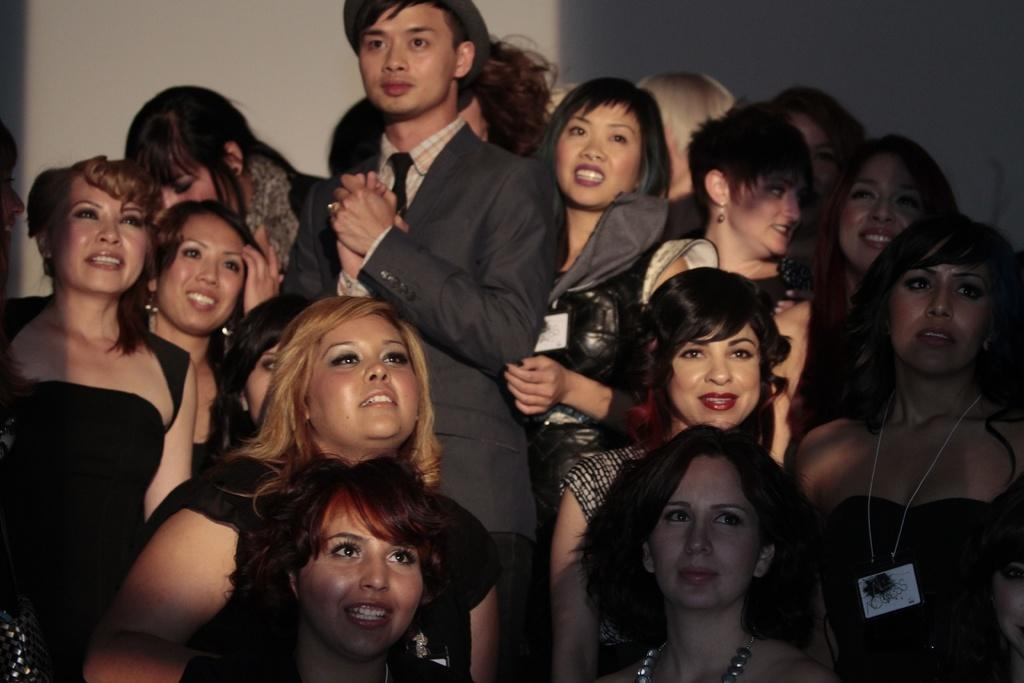How many people are in the image? There are persons standing in the image. What are the people wearing? The persons are wearing clothes. Can you describe the person in the middle of the image? The person in the middle is wearing a hat. What type of cork is the person in the middle holding in the image? There is no cork present in the image. How many buckets can be seen in the image? There is no bucket present in the image. 